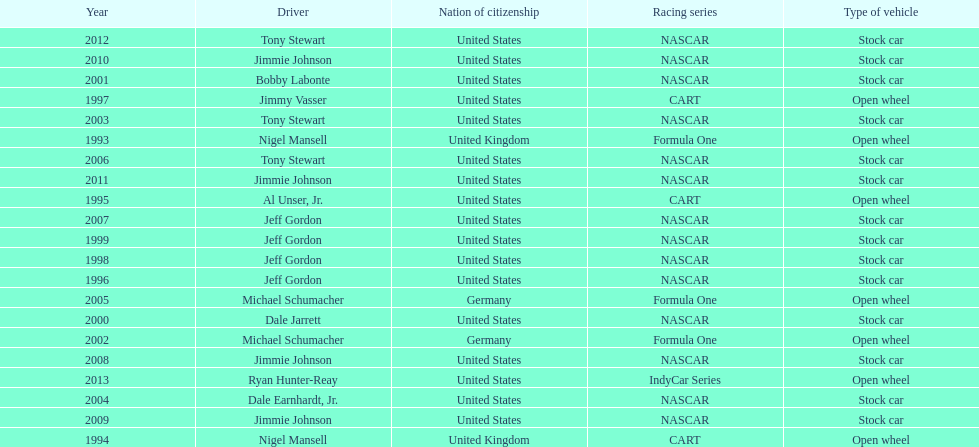Besides nascar, what other racing series have espy-winning drivers come from? Formula One, CART, IndyCar Series. 